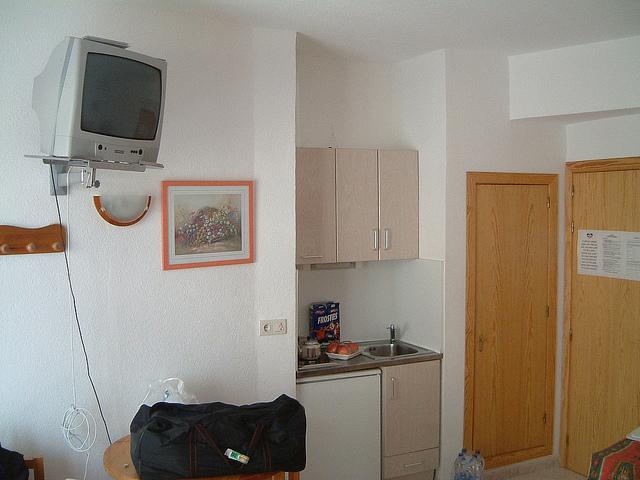What color is the photo frame?
Be succinct. Red. How many cabinets are shown?
Give a very brief answer. 3. What color is the door?
Give a very brief answer. Brown. 